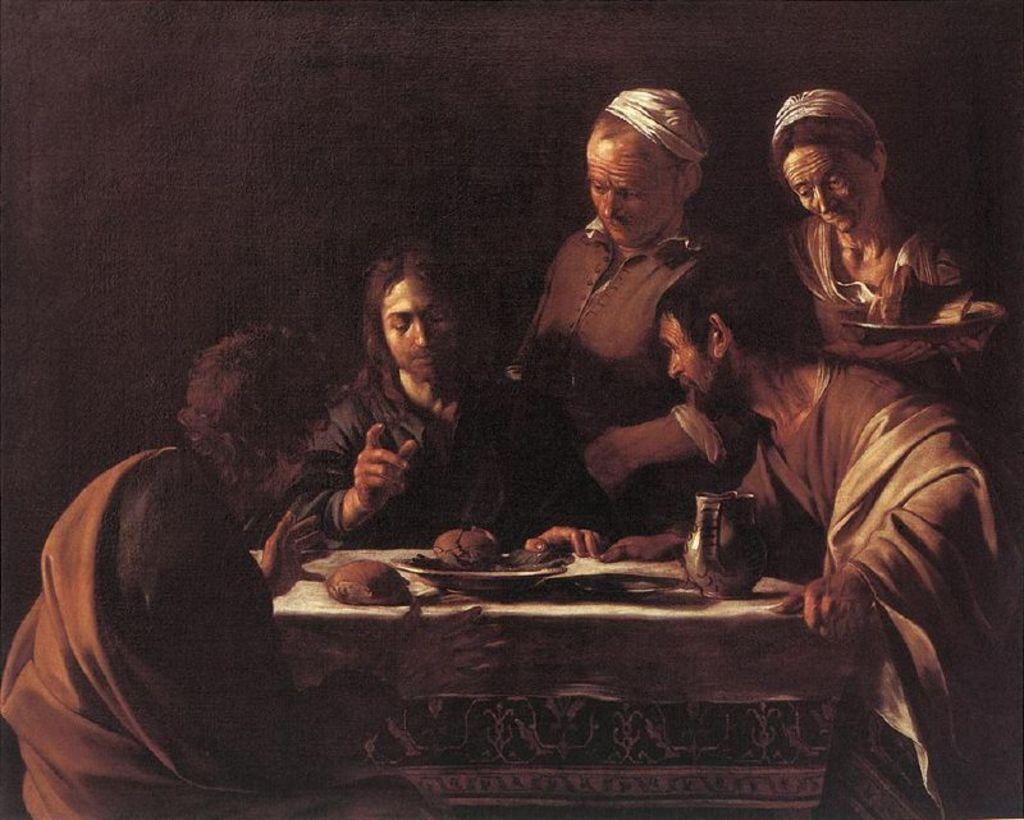How many people are present in the image? There are three persons sitting around a dining table and two persons standing on the right side, making a total of five people in the image. What are the people in the image doing? The people sitting at the table are talking. Can you describe the setting of the image? The image is a painting of people gathered around a dining table. What type of square object can be seen on the table in the image? There is no square object present on the table in the image. Are there any police officers visible in the image? There are no police officers present in the image. 